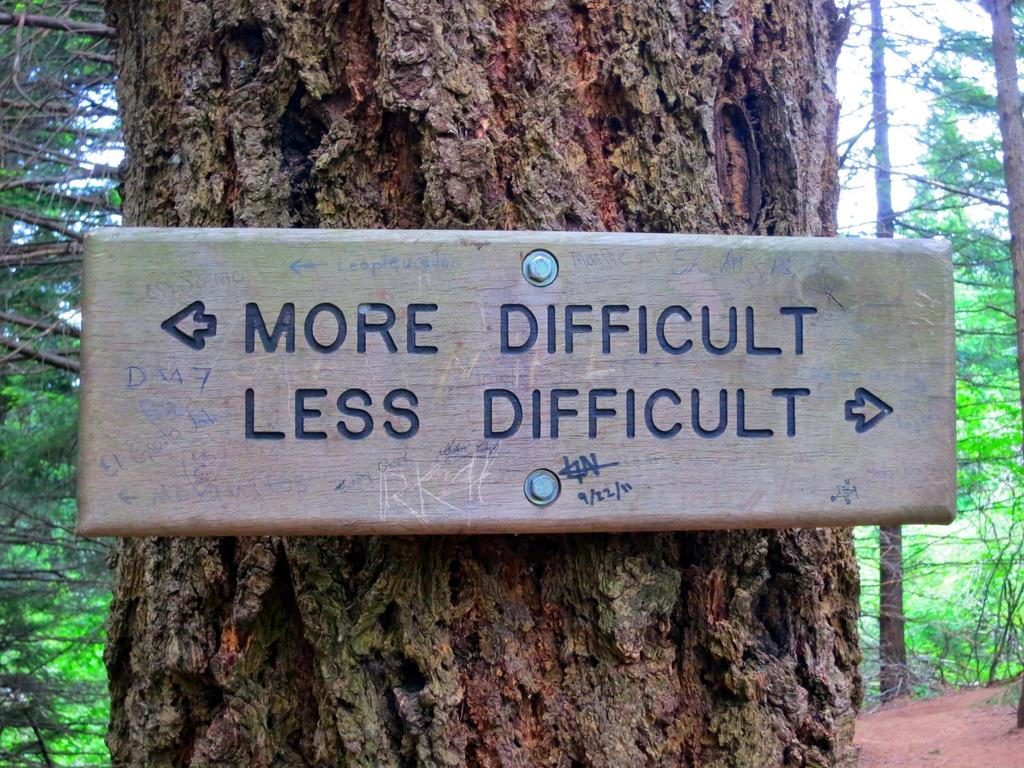What type of vegetation can be seen in the image? There are trees in the image. What is attached to one of the trees in the image? There is a board on a tree in the image. What is written on the board? There is text on the board. What is visible at the top of the image? The sky is visible at the top of the image. What is visible at the bottom of the image? The ground is visible at the bottom of the image. What type of pest can be seen crawling on the board in the image? There are no pests visible on the board in the image. What type of pen is used to write the text on the board? There is no pen visible in the image, and the method of writing the text is not mentioned. 